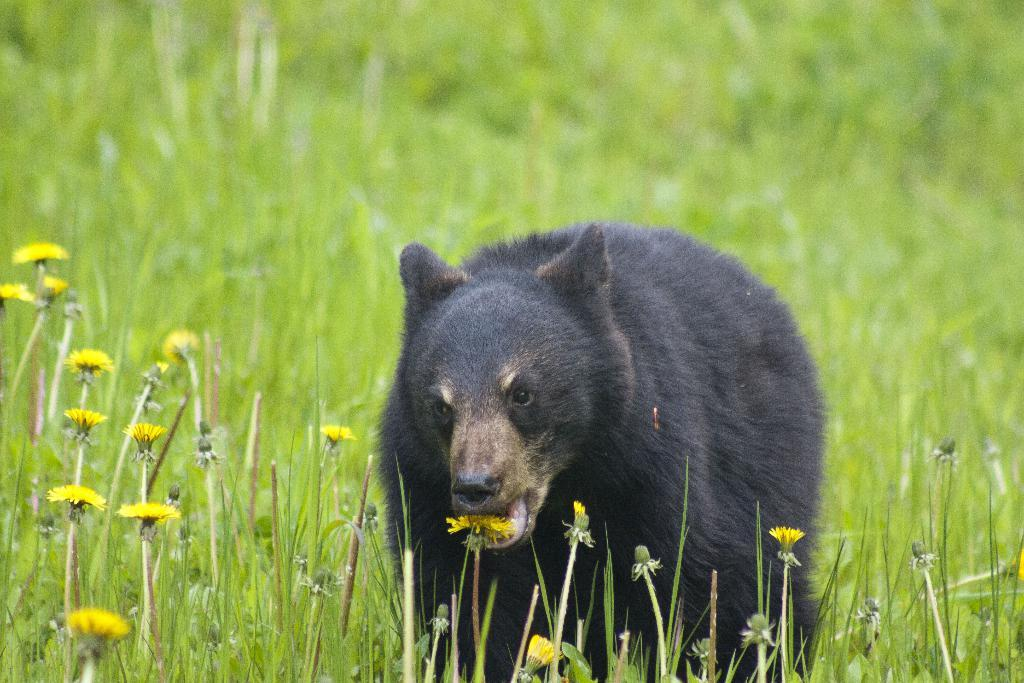What animal is present in the image? There is a bear in the image. Where is the bear located? The bear is in the grass. What type of vegetation can be seen in the image? There are flowers and plants in the image. Can you see a ghost playing with the bear in the image? No, there is no ghost or any indication of play in the image. 